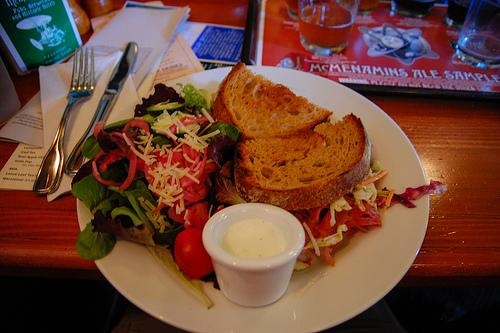Explain the chief elements in the image using brief and concise language. A white plate holds a meal of sandwich, salad, and dressing, with accompanying utensils on a napkin, situated on a wooden table. Please provide a brief description of the primary elements in the photograph. A white plate filled with salad, a grilled sandwich, and a cup of dressing, with a fork, knife and napkin nearby, all on a wooden table. Can you encapsulate the image contents in a brief yet comprehensive manner? The image features a meal setup with a white plate, salad, sandwich, dressing, silverware and a napkin, resting on a wooden table. Please outline the main aspects of the visual in a succinct representation. Food on white plate, toasted sandwich, green salad, dressing, fork and knife on napkin, located on a table. In a few words, explain the principal objects captured in this photograph. White plate with sandwich, salad, dressing, and silverware on a napkin, all on a wooden table. Can you give a compact overview of the main items shown within this image? On a wooden table, there's a white plate with food, a grilled sandwich, salad, dressing, a fork, and a knife placed on a napkin. Would you be able to recap the primary scene of this image in a concise manner? An appetizing meal of salad, grilled sandwich, and dressing on a white plate, surrounded by utensils and a napkin, placed on a wooden table. Provide an abridged explanation of the image's main subjects. The picture displays a white plate containing food, silverware, grilled sandwich, salad, and dressing, placed on a wooden table. Elaborate on a summary of the key components found within the image. The picture showcases a meal consisting of a green salad, a toasted meat and cheese sandwich, and ranch dressing on a white plate, accompanied by silverware and a napkin. I'd like a condensed description that sums up the focal contents of this picture. Grilled sandwich, salad, dressing on a white plate, with fork and knife on a napkin, displayed on a wooden table. 